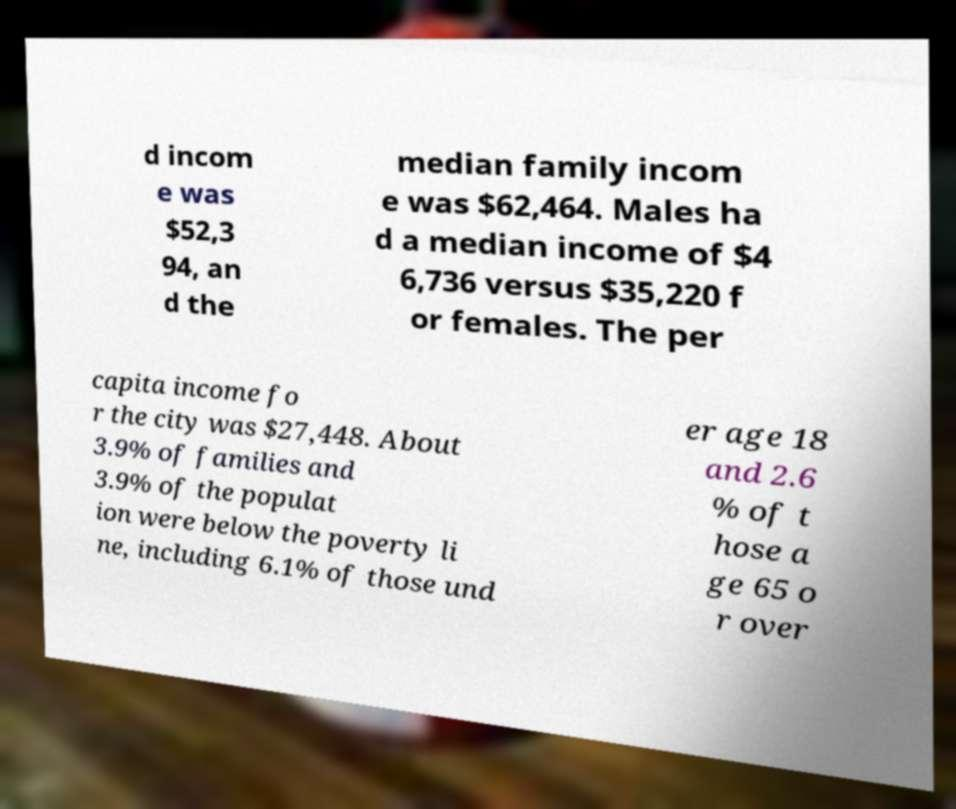Please identify and transcribe the text found in this image. d incom e was $52,3 94, an d the median family incom e was $62,464. Males ha d a median income of $4 6,736 versus $35,220 f or females. The per capita income fo r the city was $27,448. About 3.9% of families and 3.9% of the populat ion were below the poverty li ne, including 6.1% of those und er age 18 and 2.6 % of t hose a ge 65 o r over 